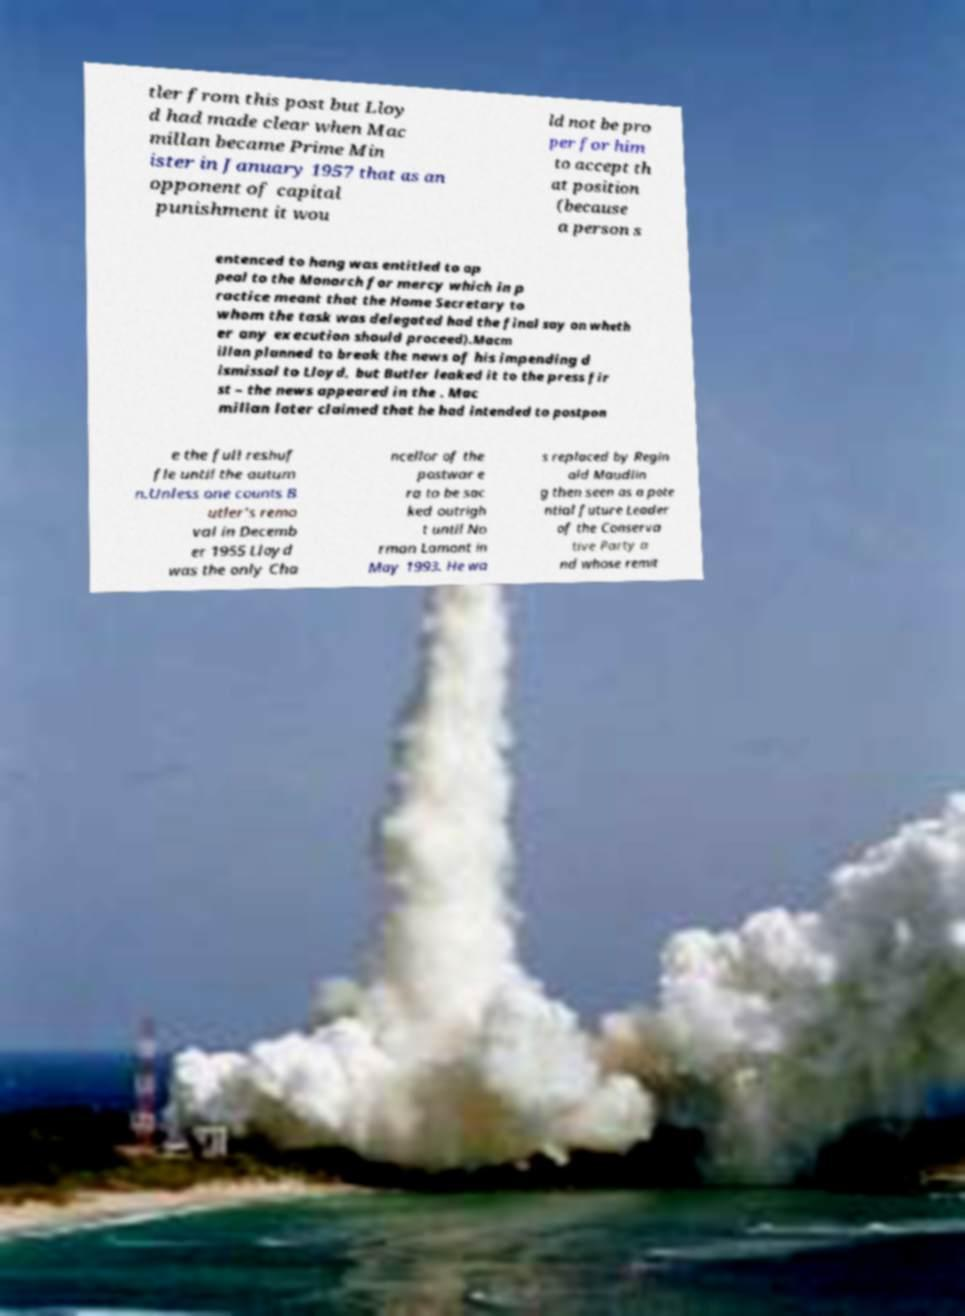There's text embedded in this image that I need extracted. Can you transcribe it verbatim? tler from this post but Lloy d had made clear when Mac millan became Prime Min ister in January 1957 that as an opponent of capital punishment it wou ld not be pro per for him to accept th at position (because a person s entenced to hang was entitled to ap peal to the Monarch for mercy which in p ractice meant that the Home Secretary to whom the task was delegated had the final say on wheth er any execution should proceed).Macm illan planned to break the news of his impending d ismissal to Lloyd, but Butler leaked it to the press fir st – the news appeared in the . Mac millan later claimed that he had intended to postpon e the full reshuf fle until the autum n.Unless one counts B utler's remo val in Decemb er 1955 Lloyd was the only Cha ncellor of the postwar e ra to be sac ked outrigh t until No rman Lamont in May 1993. He wa s replaced by Regin ald Maudlin g then seen as a pote ntial future Leader of the Conserva tive Party a nd whose remit 